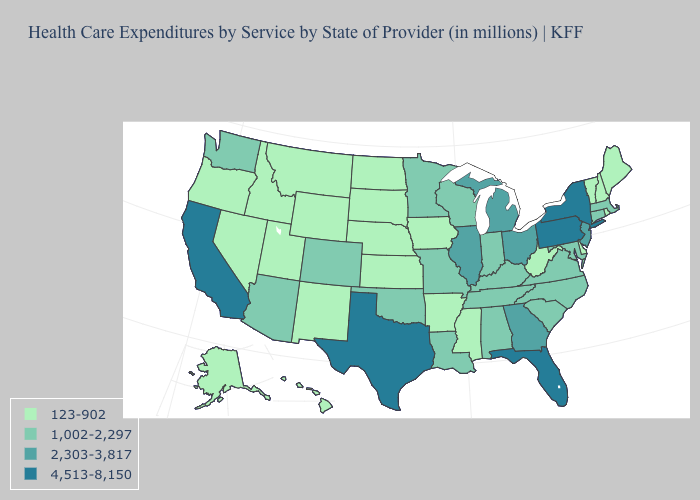Does the first symbol in the legend represent the smallest category?
Answer briefly. Yes. Name the states that have a value in the range 4,513-8,150?
Quick response, please. California, Florida, New York, Pennsylvania, Texas. What is the lowest value in the USA?
Short answer required. 123-902. Does the map have missing data?
Short answer required. No. What is the value of Montana?
Write a very short answer. 123-902. Among the states that border Louisiana , which have the highest value?
Quick response, please. Texas. What is the highest value in states that border Wyoming?
Answer briefly. 1,002-2,297. What is the lowest value in states that border North Carolina?
Give a very brief answer. 1,002-2,297. What is the lowest value in states that border Montana?
Write a very short answer. 123-902. Name the states that have a value in the range 123-902?
Give a very brief answer. Alaska, Arkansas, Delaware, Hawaii, Idaho, Iowa, Kansas, Maine, Mississippi, Montana, Nebraska, Nevada, New Hampshire, New Mexico, North Dakota, Oregon, Rhode Island, South Dakota, Utah, Vermont, West Virginia, Wyoming. What is the lowest value in the West?
Write a very short answer. 123-902. What is the highest value in states that border California?
Answer briefly. 1,002-2,297. How many symbols are there in the legend?
Answer briefly. 4. Which states hav the highest value in the West?
Quick response, please. California. 